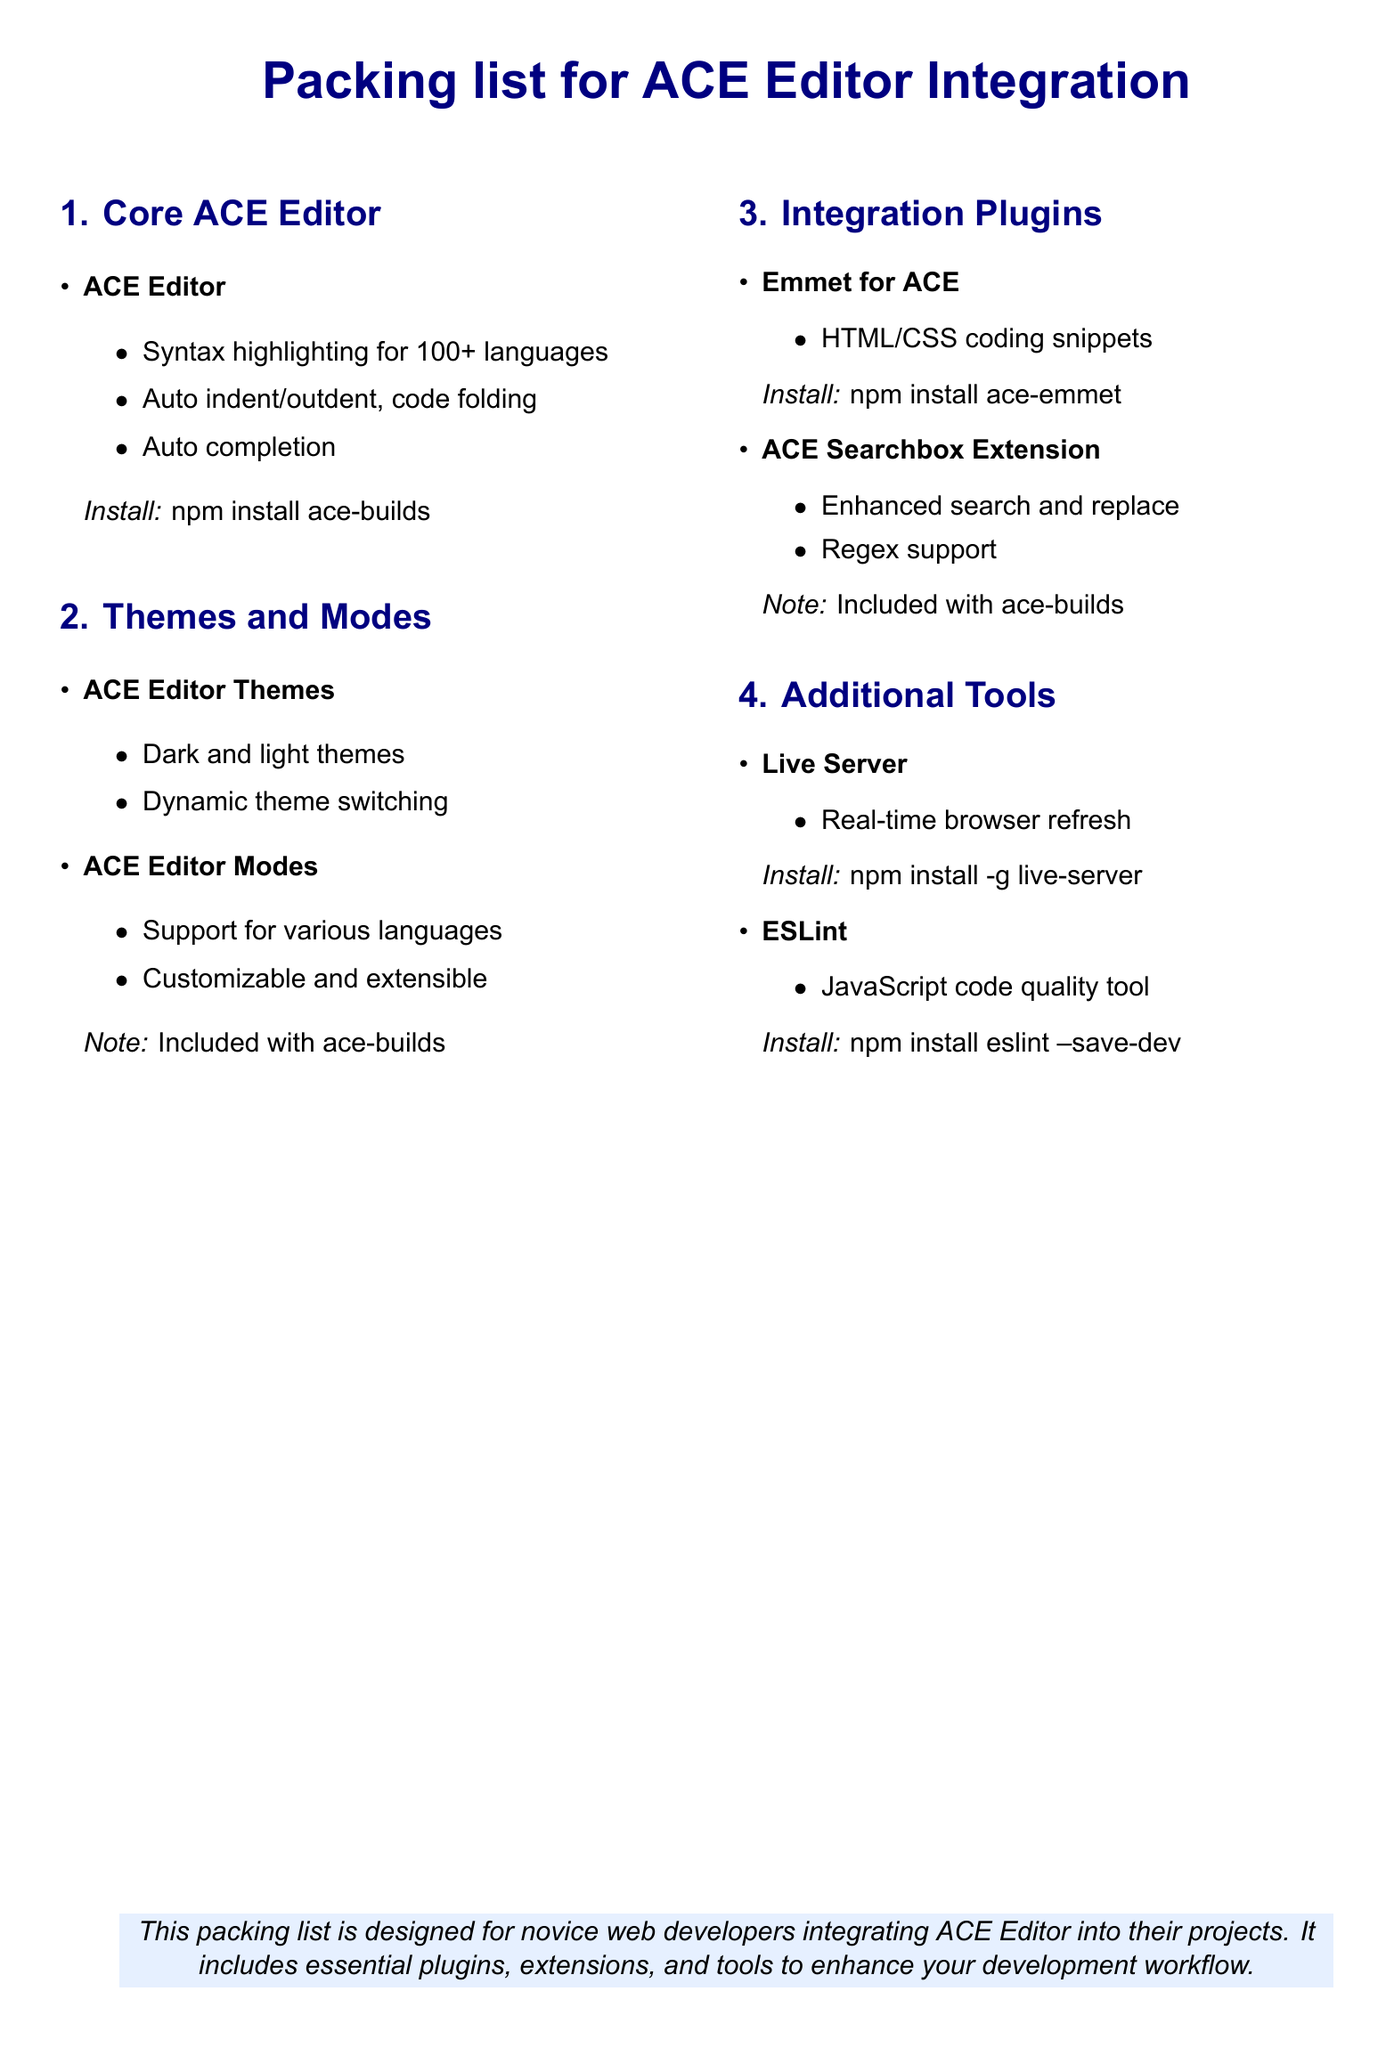What is the core ACE Editor plugin? The core ACE Editor plugin includes essential features for code editing such as syntax highlighting.
Answer: ACE Editor How many languages does ACE Editor support for syntax highlighting? The document mentions that ACE Editor supports syntax highlighting for over 100 languages.
Answer: 100+ What is the installation command for ACE Editor? The installation command for ACE Editor is provided in the document.
Answer: npm install ace-builds What additional functionality does the Emmet for ACE plugin provide? The Emmet for ACE plugin enhances coding efficiency by providing HTML and CSS snippets.
Answer: HTML/CSS coding snippets What is one feature of the Live Server tool? The document lists that Live Server provides real-time browser refresh functionality.
Answer: Real-time browser refresh Which two types of themes are available with ACE Editor? The document describes that ACE Editor includes both dark and light themes for customization.
Answer: Dark and light themes What tool is recommended for JavaScript code quality? The document recommends ESLint as a tool for maintaining JavaScript code quality.
Answer: ESLint How can you install ESLint? The document includes the installation command for ESLint as part of the required tools.
Answer: npm install eslint --save-dev What does the ACE Searchbox Extension support? The document mentions that the ACE Searchbox Extension supports enhanced search and replace with regex capabilities.
Answer: Enhanced search and replace What is the main purpose of this packing list? The document states that this packing list is designed for novice web developers integrating ACE Editor into their projects.
Answer: Novice web developers integrating ACE Editor 